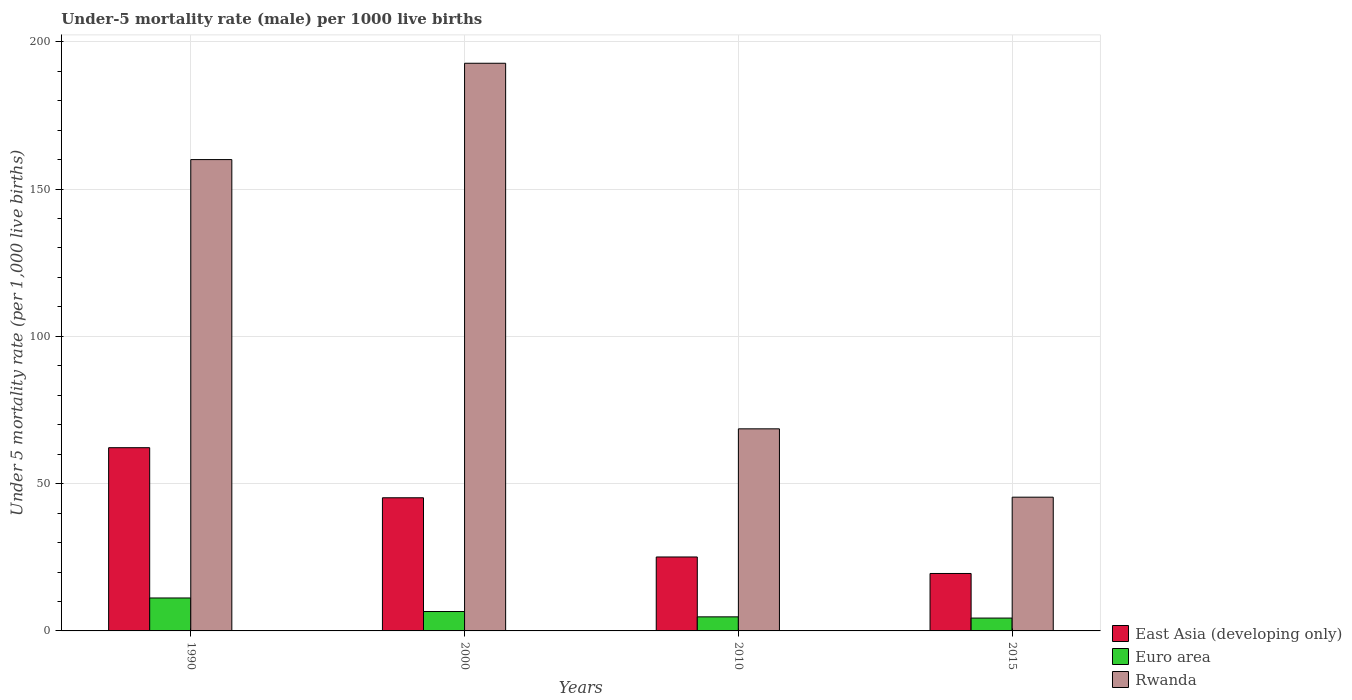How many bars are there on the 3rd tick from the right?
Ensure brevity in your answer.  3. What is the label of the 1st group of bars from the left?
Provide a short and direct response. 1990. In how many cases, is the number of bars for a given year not equal to the number of legend labels?
Ensure brevity in your answer.  0. What is the under-five mortality rate in Rwanda in 2000?
Keep it short and to the point. 192.7. Across all years, what is the maximum under-five mortality rate in Rwanda?
Your response must be concise. 192.7. Across all years, what is the minimum under-five mortality rate in Rwanda?
Keep it short and to the point. 45.4. In which year was the under-five mortality rate in Rwanda minimum?
Provide a succinct answer. 2015. What is the total under-five mortality rate in East Asia (developing only) in the graph?
Make the answer very short. 152. What is the difference between the under-five mortality rate in Euro area in 2000 and that in 2015?
Offer a terse response. 2.22. What is the difference between the under-five mortality rate in East Asia (developing only) in 2010 and the under-five mortality rate in Euro area in 2015?
Provide a short and direct response. 20.74. What is the average under-five mortality rate in Euro area per year?
Your response must be concise. 6.73. In the year 2015, what is the difference between the under-five mortality rate in Euro area and under-five mortality rate in Rwanda?
Offer a very short reply. -41.04. In how many years, is the under-five mortality rate in East Asia (developing only) greater than 60?
Keep it short and to the point. 1. What is the ratio of the under-five mortality rate in East Asia (developing only) in 2000 to that in 2015?
Keep it short and to the point. 2.32. What is the difference between the highest and the second highest under-five mortality rate in Euro area?
Ensure brevity in your answer.  4.6. What is the difference between the highest and the lowest under-five mortality rate in Rwanda?
Make the answer very short. 147.3. Is the sum of the under-five mortality rate in East Asia (developing only) in 1990 and 2010 greater than the maximum under-five mortality rate in Euro area across all years?
Your answer should be very brief. Yes. What does the 2nd bar from the left in 2010 represents?
Offer a terse response. Euro area. What does the 2nd bar from the right in 1990 represents?
Make the answer very short. Euro area. Is it the case that in every year, the sum of the under-five mortality rate in Euro area and under-five mortality rate in East Asia (developing only) is greater than the under-five mortality rate in Rwanda?
Ensure brevity in your answer.  No. How many bars are there?
Provide a succinct answer. 12. Are all the bars in the graph horizontal?
Give a very brief answer. No. How many years are there in the graph?
Provide a short and direct response. 4. Does the graph contain any zero values?
Your answer should be very brief. No. Does the graph contain grids?
Your answer should be very brief. Yes. Where does the legend appear in the graph?
Provide a succinct answer. Bottom right. How many legend labels are there?
Keep it short and to the point. 3. What is the title of the graph?
Give a very brief answer. Under-5 mortality rate (male) per 1000 live births. What is the label or title of the X-axis?
Offer a very short reply. Years. What is the label or title of the Y-axis?
Keep it short and to the point. Under 5 mortality rate (per 1,0 live births). What is the Under 5 mortality rate (per 1,000 live births) of East Asia (developing only) in 1990?
Ensure brevity in your answer.  62.2. What is the Under 5 mortality rate (per 1,000 live births) in Euro area in 1990?
Your answer should be compact. 11.19. What is the Under 5 mortality rate (per 1,000 live births) of Rwanda in 1990?
Provide a short and direct response. 160. What is the Under 5 mortality rate (per 1,000 live births) in East Asia (developing only) in 2000?
Provide a short and direct response. 45.2. What is the Under 5 mortality rate (per 1,000 live births) of Euro area in 2000?
Offer a terse response. 6.58. What is the Under 5 mortality rate (per 1,000 live births) in Rwanda in 2000?
Offer a terse response. 192.7. What is the Under 5 mortality rate (per 1,000 live births) in East Asia (developing only) in 2010?
Provide a succinct answer. 25.1. What is the Under 5 mortality rate (per 1,000 live births) in Euro area in 2010?
Provide a short and direct response. 4.78. What is the Under 5 mortality rate (per 1,000 live births) in Rwanda in 2010?
Your answer should be compact. 68.6. What is the Under 5 mortality rate (per 1,000 live births) of Euro area in 2015?
Your answer should be compact. 4.36. What is the Under 5 mortality rate (per 1,000 live births) in Rwanda in 2015?
Offer a very short reply. 45.4. Across all years, what is the maximum Under 5 mortality rate (per 1,000 live births) in East Asia (developing only)?
Offer a very short reply. 62.2. Across all years, what is the maximum Under 5 mortality rate (per 1,000 live births) of Euro area?
Ensure brevity in your answer.  11.19. Across all years, what is the maximum Under 5 mortality rate (per 1,000 live births) of Rwanda?
Offer a terse response. 192.7. Across all years, what is the minimum Under 5 mortality rate (per 1,000 live births) of Euro area?
Provide a succinct answer. 4.36. Across all years, what is the minimum Under 5 mortality rate (per 1,000 live births) in Rwanda?
Ensure brevity in your answer.  45.4. What is the total Under 5 mortality rate (per 1,000 live births) of East Asia (developing only) in the graph?
Give a very brief answer. 152. What is the total Under 5 mortality rate (per 1,000 live births) of Euro area in the graph?
Make the answer very short. 26.91. What is the total Under 5 mortality rate (per 1,000 live births) in Rwanda in the graph?
Give a very brief answer. 466.7. What is the difference between the Under 5 mortality rate (per 1,000 live births) of Euro area in 1990 and that in 2000?
Keep it short and to the point. 4.6. What is the difference between the Under 5 mortality rate (per 1,000 live births) of Rwanda in 1990 and that in 2000?
Your answer should be very brief. -32.7. What is the difference between the Under 5 mortality rate (per 1,000 live births) in East Asia (developing only) in 1990 and that in 2010?
Keep it short and to the point. 37.1. What is the difference between the Under 5 mortality rate (per 1,000 live births) of Euro area in 1990 and that in 2010?
Make the answer very short. 6.41. What is the difference between the Under 5 mortality rate (per 1,000 live births) of Rwanda in 1990 and that in 2010?
Your response must be concise. 91.4. What is the difference between the Under 5 mortality rate (per 1,000 live births) in East Asia (developing only) in 1990 and that in 2015?
Provide a short and direct response. 42.7. What is the difference between the Under 5 mortality rate (per 1,000 live births) in Euro area in 1990 and that in 2015?
Make the answer very short. 6.83. What is the difference between the Under 5 mortality rate (per 1,000 live births) in Rwanda in 1990 and that in 2015?
Your response must be concise. 114.6. What is the difference between the Under 5 mortality rate (per 1,000 live births) in East Asia (developing only) in 2000 and that in 2010?
Keep it short and to the point. 20.1. What is the difference between the Under 5 mortality rate (per 1,000 live births) of Euro area in 2000 and that in 2010?
Give a very brief answer. 1.81. What is the difference between the Under 5 mortality rate (per 1,000 live births) in Rwanda in 2000 and that in 2010?
Offer a very short reply. 124.1. What is the difference between the Under 5 mortality rate (per 1,000 live births) in East Asia (developing only) in 2000 and that in 2015?
Ensure brevity in your answer.  25.7. What is the difference between the Under 5 mortality rate (per 1,000 live births) in Euro area in 2000 and that in 2015?
Offer a very short reply. 2.22. What is the difference between the Under 5 mortality rate (per 1,000 live births) in Rwanda in 2000 and that in 2015?
Your response must be concise. 147.3. What is the difference between the Under 5 mortality rate (per 1,000 live births) in East Asia (developing only) in 2010 and that in 2015?
Keep it short and to the point. 5.6. What is the difference between the Under 5 mortality rate (per 1,000 live births) in Euro area in 2010 and that in 2015?
Your answer should be very brief. 0.42. What is the difference between the Under 5 mortality rate (per 1,000 live births) of Rwanda in 2010 and that in 2015?
Your response must be concise. 23.2. What is the difference between the Under 5 mortality rate (per 1,000 live births) of East Asia (developing only) in 1990 and the Under 5 mortality rate (per 1,000 live births) of Euro area in 2000?
Your answer should be compact. 55.62. What is the difference between the Under 5 mortality rate (per 1,000 live births) of East Asia (developing only) in 1990 and the Under 5 mortality rate (per 1,000 live births) of Rwanda in 2000?
Your answer should be very brief. -130.5. What is the difference between the Under 5 mortality rate (per 1,000 live births) of Euro area in 1990 and the Under 5 mortality rate (per 1,000 live births) of Rwanda in 2000?
Make the answer very short. -181.51. What is the difference between the Under 5 mortality rate (per 1,000 live births) in East Asia (developing only) in 1990 and the Under 5 mortality rate (per 1,000 live births) in Euro area in 2010?
Your answer should be very brief. 57.42. What is the difference between the Under 5 mortality rate (per 1,000 live births) in Euro area in 1990 and the Under 5 mortality rate (per 1,000 live births) in Rwanda in 2010?
Keep it short and to the point. -57.41. What is the difference between the Under 5 mortality rate (per 1,000 live births) of East Asia (developing only) in 1990 and the Under 5 mortality rate (per 1,000 live births) of Euro area in 2015?
Offer a terse response. 57.84. What is the difference between the Under 5 mortality rate (per 1,000 live births) of East Asia (developing only) in 1990 and the Under 5 mortality rate (per 1,000 live births) of Rwanda in 2015?
Give a very brief answer. 16.8. What is the difference between the Under 5 mortality rate (per 1,000 live births) of Euro area in 1990 and the Under 5 mortality rate (per 1,000 live births) of Rwanda in 2015?
Your answer should be compact. -34.21. What is the difference between the Under 5 mortality rate (per 1,000 live births) in East Asia (developing only) in 2000 and the Under 5 mortality rate (per 1,000 live births) in Euro area in 2010?
Offer a very short reply. 40.42. What is the difference between the Under 5 mortality rate (per 1,000 live births) in East Asia (developing only) in 2000 and the Under 5 mortality rate (per 1,000 live births) in Rwanda in 2010?
Provide a succinct answer. -23.4. What is the difference between the Under 5 mortality rate (per 1,000 live births) of Euro area in 2000 and the Under 5 mortality rate (per 1,000 live births) of Rwanda in 2010?
Provide a short and direct response. -62.02. What is the difference between the Under 5 mortality rate (per 1,000 live births) of East Asia (developing only) in 2000 and the Under 5 mortality rate (per 1,000 live births) of Euro area in 2015?
Give a very brief answer. 40.84. What is the difference between the Under 5 mortality rate (per 1,000 live births) of East Asia (developing only) in 2000 and the Under 5 mortality rate (per 1,000 live births) of Rwanda in 2015?
Keep it short and to the point. -0.2. What is the difference between the Under 5 mortality rate (per 1,000 live births) of Euro area in 2000 and the Under 5 mortality rate (per 1,000 live births) of Rwanda in 2015?
Ensure brevity in your answer.  -38.82. What is the difference between the Under 5 mortality rate (per 1,000 live births) of East Asia (developing only) in 2010 and the Under 5 mortality rate (per 1,000 live births) of Euro area in 2015?
Give a very brief answer. 20.74. What is the difference between the Under 5 mortality rate (per 1,000 live births) in East Asia (developing only) in 2010 and the Under 5 mortality rate (per 1,000 live births) in Rwanda in 2015?
Offer a terse response. -20.3. What is the difference between the Under 5 mortality rate (per 1,000 live births) of Euro area in 2010 and the Under 5 mortality rate (per 1,000 live births) of Rwanda in 2015?
Make the answer very short. -40.62. What is the average Under 5 mortality rate (per 1,000 live births) in East Asia (developing only) per year?
Your answer should be compact. 38. What is the average Under 5 mortality rate (per 1,000 live births) in Euro area per year?
Give a very brief answer. 6.73. What is the average Under 5 mortality rate (per 1,000 live births) in Rwanda per year?
Ensure brevity in your answer.  116.67. In the year 1990, what is the difference between the Under 5 mortality rate (per 1,000 live births) in East Asia (developing only) and Under 5 mortality rate (per 1,000 live births) in Euro area?
Your answer should be compact. 51.01. In the year 1990, what is the difference between the Under 5 mortality rate (per 1,000 live births) of East Asia (developing only) and Under 5 mortality rate (per 1,000 live births) of Rwanda?
Your response must be concise. -97.8. In the year 1990, what is the difference between the Under 5 mortality rate (per 1,000 live births) of Euro area and Under 5 mortality rate (per 1,000 live births) of Rwanda?
Keep it short and to the point. -148.81. In the year 2000, what is the difference between the Under 5 mortality rate (per 1,000 live births) in East Asia (developing only) and Under 5 mortality rate (per 1,000 live births) in Euro area?
Provide a short and direct response. 38.62. In the year 2000, what is the difference between the Under 5 mortality rate (per 1,000 live births) of East Asia (developing only) and Under 5 mortality rate (per 1,000 live births) of Rwanda?
Provide a succinct answer. -147.5. In the year 2000, what is the difference between the Under 5 mortality rate (per 1,000 live births) in Euro area and Under 5 mortality rate (per 1,000 live births) in Rwanda?
Your answer should be very brief. -186.12. In the year 2010, what is the difference between the Under 5 mortality rate (per 1,000 live births) of East Asia (developing only) and Under 5 mortality rate (per 1,000 live births) of Euro area?
Your response must be concise. 20.32. In the year 2010, what is the difference between the Under 5 mortality rate (per 1,000 live births) of East Asia (developing only) and Under 5 mortality rate (per 1,000 live births) of Rwanda?
Provide a short and direct response. -43.5. In the year 2010, what is the difference between the Under 5 mortality rate (per 1,000 live births) of Euro area and Under 5 mortality rate (per 1,000 live births) of Rwanda?
Provide a succinct answer. -63.82. In the year 2015, what is the difference between the Under 5 mortality rate (per 1,000 live births) of East Asia (developing only) and Under 5 mortality rate (per 1,000 live births) of Euro area?
Offer a terse response. 15.14. In the year 2015, what is the difference between the Under 5 mortality rate (per 1,000 live births) of East Asia (developing only) and Under 5 mortality rate (per 1,000 live births) of Rwanda?
Offer a terse response. -25.9. In the year 2015, what is the difference between the Under 5 mortality rate (per 1,000 live births) of Euro area and Under 5 mortality rate (per 1,000 live births) of Rwanda?
Offer a very short reply. -41.04. What is the ratio of the Under 5 mortality rate (per 1,000 live births) in East Asia (developing only) in 1990 to that in 2000?
Ensure brevity in your answer.  1.38. What is the ratio of the Under 5 mortality rate (per 1,000 live births) of Euro area in 1990 to that in 2000?
Ensure brevity in your answer.  1.7. What is the ratio of the Under 5 mortality rate (per 1,000 live births) of Rwanda in 1990 to that in 2000?
Make the answer very short. 0.83. What is the ratio of the Under 5 mortality rate (per 1,000 live births) of East Asia (developing only) in 1990 to that in 2010?
Ensure brevity in your answer.  2.48. What is the ratio of the Under 5 mortality rate (per 1,000 live births) of Euro area in 1990 to that in 2010?
Offer a terse response. 2.34. What is the ratio of the Under 5 mortality rate (per 1,000 live births) in Rwanda in 1990 to that in 2010?
Your answer should be very brief. 2.33. What is the ratio of the Under 5 mortality rate (per 1,000 live births) of East Asia (developing only) in 1990 to that in 2015?
Provide a succinct answer. 3.19. What is the ratio of the Under 5 mortality rate (per 1,000 live births) of Euro area in 1990 to that in 2015?
Your response must be concise. 2.57. What is the ratio of the Under 5 mortality rate (per 1,000 live births) in Rwanda in 1990 to that in 2015?
Your response must be concise. 3.52. What is the ratio of the Under 5 mortality rate (per 1,000 live births) of East Asia (developing only) in 2000 to that in 2010?
Provide a short and direct response. 1.8. What is the ratio of the Under 5 mortality rate (per 1,000 live births) of Euro area in 2000 to that in 2010?
Give a very brief answer. 1.38. What is the ratio of the Under 5 mortality rate (per 1,000 live births) of Rwanda in 2000 to that in 2010?
Your response must be concise. 2.81. What is the ratio of the Under 5 mortality rate (per 1,000 live births) in East Asia (developing only) in 2000 to that in 2015?
Your answer should be compact. 2.32. What is the ratio of the Under 5 mortality rate (per 1,000 live births) in Euro area in 2000 to that in 2015?
Your response must be concise. 1.51. What is the ratio of the Under 5 mortality rate (per 1,000 live births) of Rwanda in 2000 to that in 2015?
Make the answer very short. 4.24. What is the ratio of the Under 5 mortality rate (per 1,000 live births) in East Asia (developing only) in 2010 to that in 2015?
Provide a succinct answer. 1.29. What is the ratio of the Under 5 mortality rate (per 1,000 live births) of Euro area in 2010 to that in 2015?
Make the answer very short. 1.1. What is the ratio of the Under 5 mortality rate (per 1,000 live births) in Rwanda in 2010 to that in 2015?
Provide a short and direct response. 1.51. What is the difference between the highest and the second highest Under 5 mortality rate (per 1,000 live births) of East Asia (developing only)?
Keep it short and to the point. 17. What is the difference between the highest and the second highest Under 5 mortality rate (per 1,000 live births) of Euro area?
Your answer should be very brief. 4.6. What is the difference between the highest and the second highest Under 5 mortality rate (per 1,000 live births) in Rwanda?
Offer a very short reply. 32.7. What is the difference between the highest and the lowest Under 5 mortality rate (per 1,000 live births) of East Asia (developing only)?
Provide a short and direct response. 42.7. What is the difference between the highest and the lowest Under 5 mortality rate (per 1,000 live births) in Euro area?
Make the answer very short. 6.83. What is the difference between the highest and the lowest Under 5 mortality rate (per 1,000 live births) of Rwanda?
Provide a short and direct response. 147.3. 